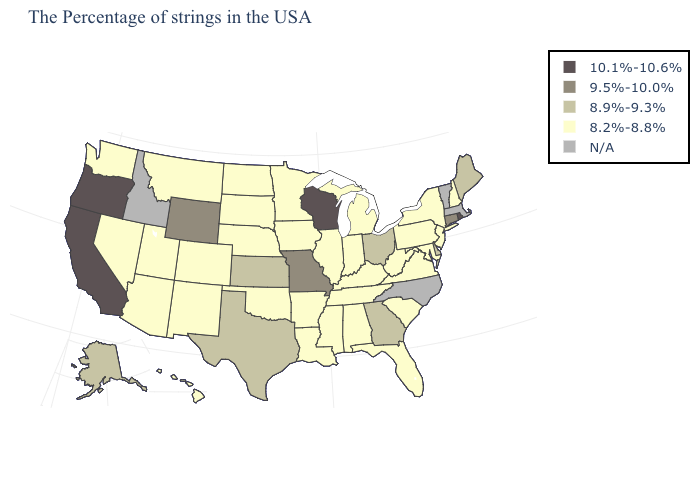Does South Carolina have the lowest value in the South?
Give a very brief answer. Yes. Name the states that have a value in the range 8.9%-9.3%?
Short answer required. Maine, Delaware, Ohio, Georgia, Kansas, Texas, Alaska. Does the first symbol in the legend represent the smallest category?
Quick response, please. No. Name the states that have a value in the range N/A?
Be succinct. Massachusetts, Vermont, North Carolina, Idaho. Does the first symbol in the legend represent the smallest category?
Short answer required. No. What is the highest value in the USA?
Answer briefly. 10.1%-10.6%. Name the states that have a value in the range 8.9%-9.3%?
Write a very short answer. Maine, Delaware, Ohio, Georgia, Kansas, Texas, Alaska. Does Iowa have the lowest value in the MidWest?
Short answer required. Yes. Name the states that have a value in the range 8.9%-9.3%?
Write a very short answer. Maine, Delaware, Ohio, Georgia, Kansas, Texas, Alaska. Among the states that border Washington , which have the lowest value?
Give a very brief answer. Oregon. Which states hav the highest value in the South?
Give a very brief answer. Delaware, Georgia, Texas. What is the value of Louisiana?
Answer briefly. 8.2%-8.8%. Name the states that have a value in the range 9.5%-10.0%?
Answer briefly. Connecticut, Missouri, Wyoming. What is the lowest value in the South?
Short answer required. 8.2%-8.8%. What is the lowest value in the USA?
Answer briefly. 8.2%-8.8%. 